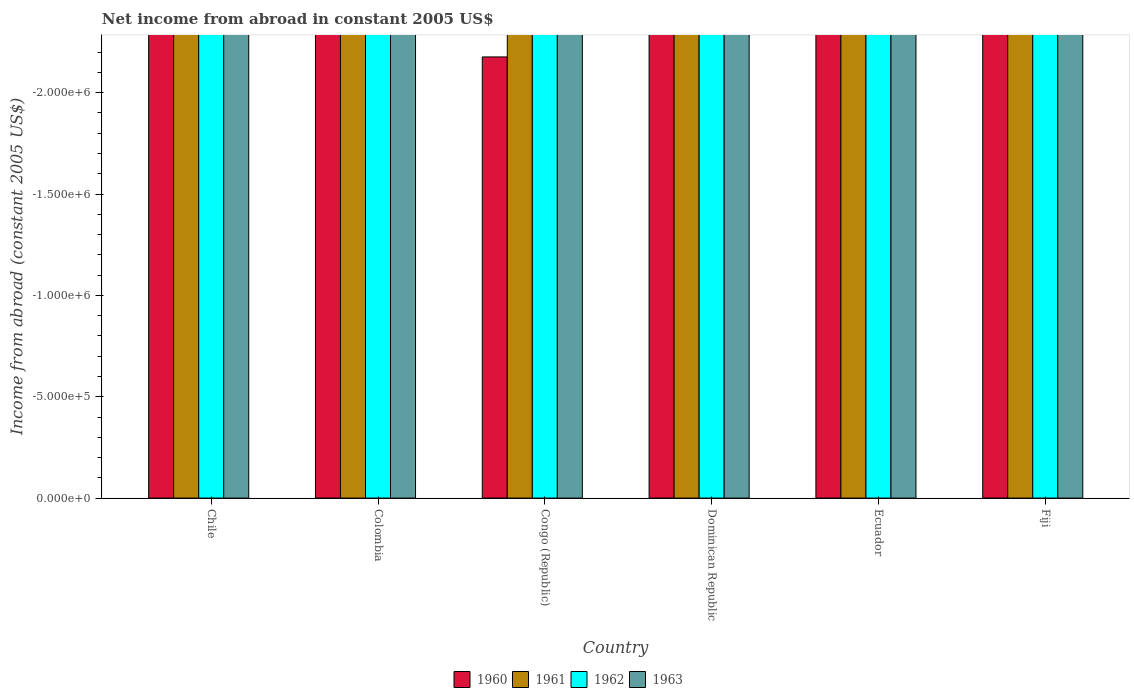Are the number of bars on each tick of the X-axis equal?
Provide a short and direct response. Yes. What is the label of the 4th group of bars from the left?
Make the answer very short. Dominican Republic. What is the net income from abroad in 1961 in Colombia?
Ensure brevity in your answer.  0. What is the total net income from abroad in 1963 in the graph?
Ensure brevity in your answer.  0. What is the difference between the net income from abroad in 1961 in Congo (Republic) and the net income from abroad in 1962 in Colombia?
Offer a terse response. 0. In how many countries, is the net income from abroad in 1962 greater than -700000 US$?
Make the answer very short. 0. In how many countries, is the net income from abroad in 1962 greater than the average net income from abroad in 1962 taken over all countries?
Offer a very short reply. 0. Is it the case that in every country, the sum of the net income from abroad in 1963 and net income from abroad in 1962 is greater than the sum of net income from abroad in 1960 and net income from abroad in 1961?
Ensure brevity in your answer.  No. How many bars are there?
Provide a succinct answer. 0. Are all the bars in the graph horizontal?
Ensure brevity in your answer.  No. What is the difference between two consecutive major ticks on the Y-axis?
Keep it short and to the point. 5.00e+05. Does the graph contain grids?
Offer a terse response. No. Where does the legend appear in the graph?
Provide a succinct answer. Bottom center. How are the legend labels stacked?
Provide a short and direct response. Horizontal. What is the title of the graph?
Your response must be concise. Net income from abroad in constant 2005 US$. What is the label or title of the X-axis?
Give a very brief answer. Country. What is the label or title of the Y-axis?
Offer a very short reply. Income from abroad (constant 2005 US$). What is the Income from abroad (constant 2005 US$) of 1963 in Chile?
Provide a succinct answer. 0. What is the Income from abroad (constant 2005 US$) in 1962 in Congo (Republic)?
Your response must be concise. 0. What is the Income from abroad (constant 2005 US$) in 1960 in Ecuador?
Keep it short and to the point. 0. What is the Income from abroad (constant 2005 US$) of 1962 in Ecuador?
Give a very brief answer. 0. What is the Income from abroad (constant 2005 US$) in 1962 in Fiji?
Ensure brevity in your answer.  0. What is the Income from abroad (constant 2005 US$) in 1963 in Fiji?
Your response must be concise. 0. What is the total Income from abroad (constant 2005 US$) in 1960 in the graph?
Offer a very short reply. 0. What is the total Income from abroad (constant 2005 US$) in 1961 in the graph?
Your answer should be compact. 0. What is the total Income from abroad (constant 2005 US$) of 1962 in the graph?
Offer a terse response. 0. What is the total Income from abroad (constant 2005 US$) in 1963 in the graph?
Offer a very short reply. 0. What is the average Income from abroad (constant 2005 US$) in 1962 per country?
Offer a terse response. 0. 